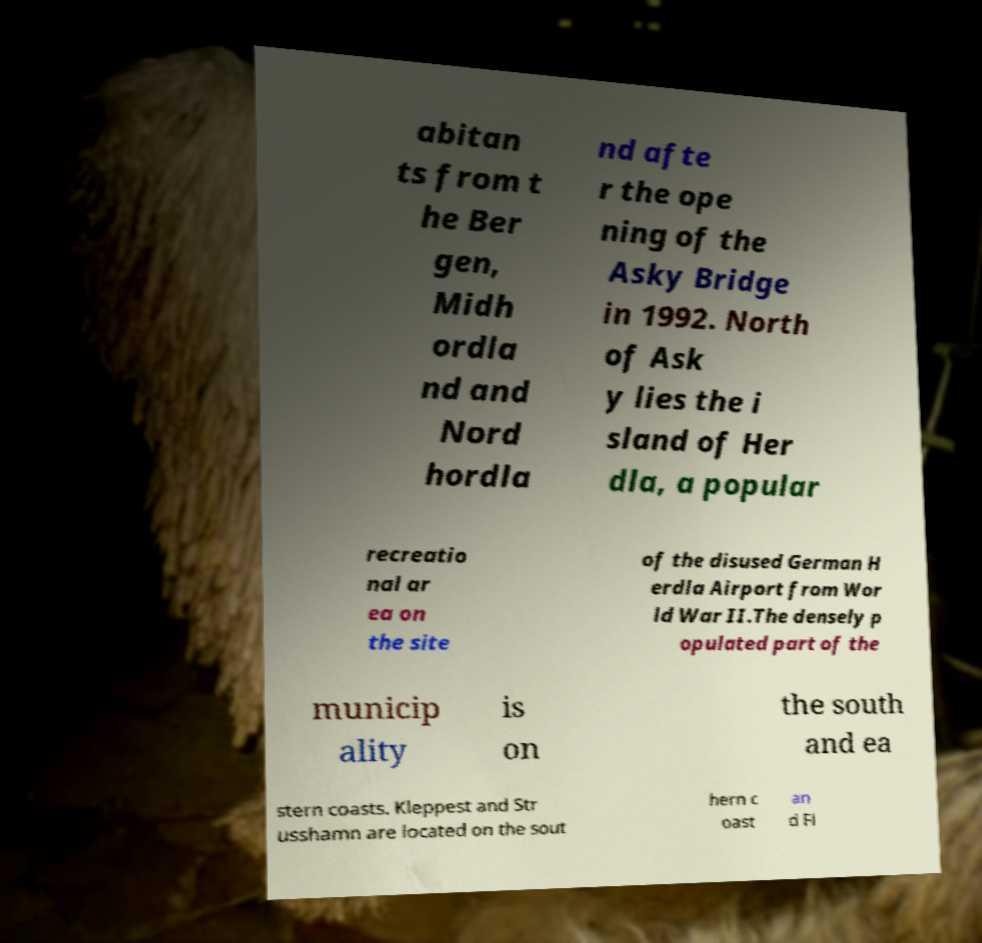Can you accurately transcribe the text from the provided image for me? abitan ts from t he Ber gen, Midh ordla nd and Nord hordla nd afte r the ope ning of the Asky Bridge in 1992. North of Ask y lies the i sland of Her dla, a popular recreatio nal ar ea on the site of the disused German H erdla Airport from Wor ld War II.The densely p opulated part of the municip ality is on the south and ea stern coasts. Kleppest and Str usshamn are located on the sout hern c oast an d Fl 